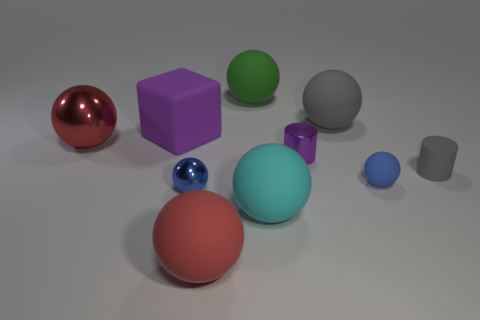Which objects in the image are closest to the camera? The red sphere in the foreground appears to be closest to the camera, followed by the large teal sphere slightly further back and to the left. 